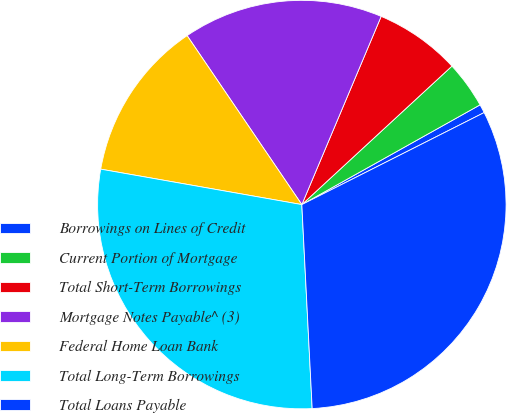Convert chart. <chart><loc_0><loc_0><loc_500><loc_500><pie_chart><fcel>Borrowings on Lines of Credit<fcel>Current Portion of Mortgage<fcel>Total Short-Term Borrowings<fcel>Mortgage Notes Payable^ (3)<fcel>Federal Home Loan Bank<fcel>Total Long-Term Borrowings<fcel>Total Loans Payable<nl><fcel>0.68%<fcel>3.74%<fcel>6.79%<fcel>15.84%<fcel>12.73%<fcel>28.58%<fcel>31.63%<nl></chart> 